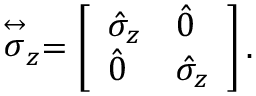Convert formula to latex. <formula><loc_0><loc_0><loc_500><loc_500>\stackrel { \leftrightarrow } { \sigma } _ { z } = \left [ \begin{array} { l l } { \hat { \sigma } _ { z } } & { \hat { 0 } } \\ { \hat { 0 } } & { \hat { \sigma } _ { z } } \end{array} \right ] .</formula> 